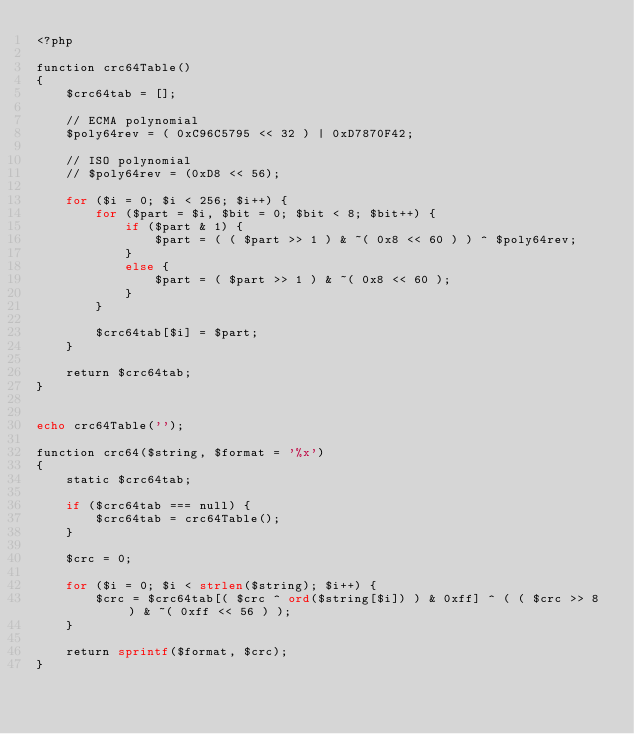Convert code to text. <code><loc_0><loc_0><loc_500><loc_500><_PHP_><?php

function crc64Table()
{
    $crc64tab = [];

    // ECMA polynomial
    $poly64rev = ( 0xC96C5795 << 32 ) | 0xD7870F42;

    // ISO polynomial
    // $poly64rev = (0xD8 << 56);

    for ($i = 0; $i < 256; $i++) {
        for ($part = $i, $bit = 0; $bit < 8; $bit++) {
            if ($part & 1) {
                $part = ( ( $part >> 1 ) & ~( 0x8 << 60 ) ) ^ $poly64rev;
            }
            else {
                $part = ( $part >> 1 ) & ~( 0x8 << 60 );
            }
        }

        $crc64tab[$i] = $part;
    }

    return $crc64tab;
}


echo crc64Table('');

function crc64($string, $format = '%x')
{
    static $crc64tab;

    if ($crc64tab === null) {
        $crc64tab = crc64Table();
    }

    $crc = 0;

    for ($i = 0; $i < strlen($string); $i++) {
        $crc = $crc64tab[( $crc ^ ord($string[$i]) ) & 0xff] ^ ( ( $crc >> 8 ) & ~( 0xff << 56 ) );
    }

    return sprintf($format, $crc);
}


</code> 